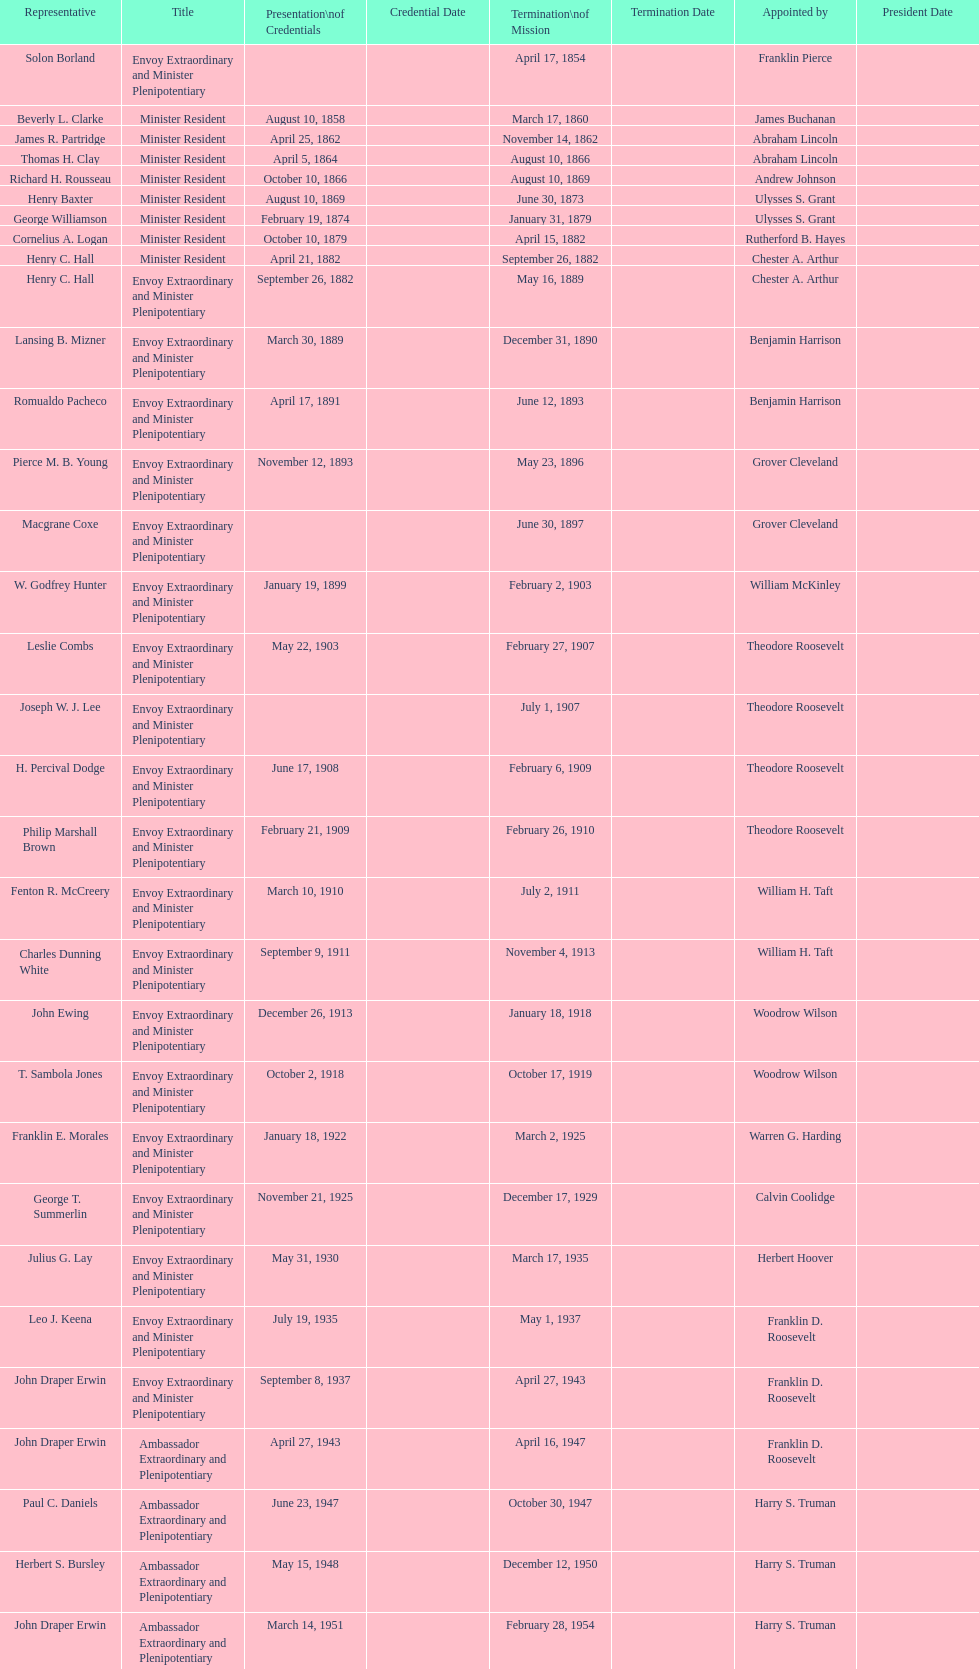Which date is below april 17, 1854 March 17, 1860. 